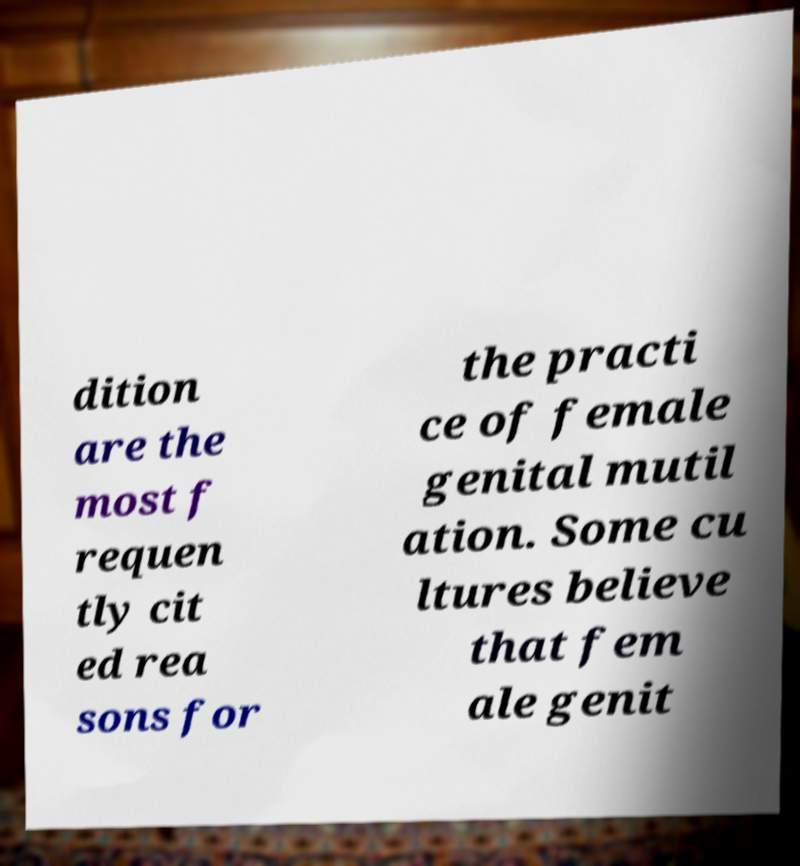Please read and relay the text visible in this image. What does it say? dition are the most f requen tly cit ed rea sons for the practi ce of female genital mutil ation. Some cu ltures believe that fem ale genit 